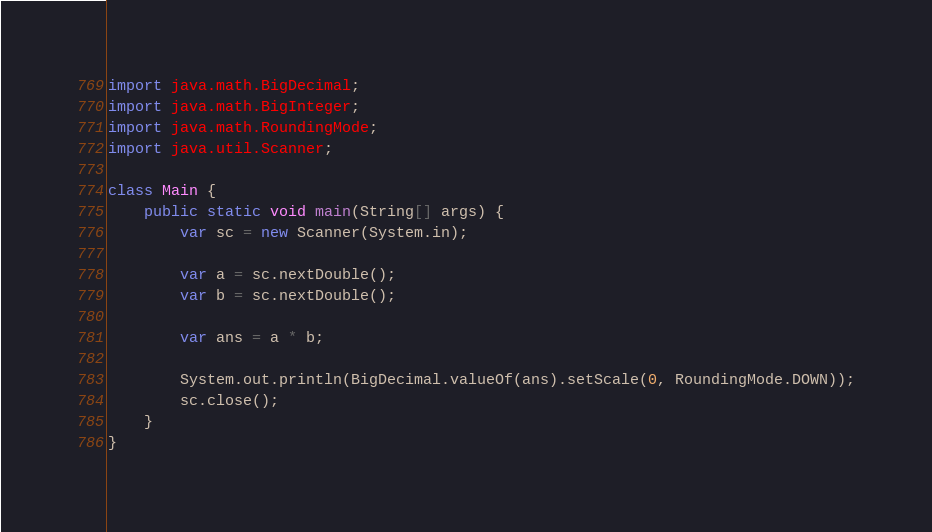Convert code to text. <code><loc_0><loc_0><loc_500><loc_500><_Java_>import java.math.BigDecimal;
import java.math.BigInteger;
import java.math.RoundingMode;
import java.util.Scanner;

class Main {
    public static void main(String[] args) {
        var sc = new Scanner(System.in);

        var a = sc.nextDouble();
        var b = sc.nextDouble();

        var ans = a * b;

        System.out.println(BigDecimal.valueOf(ans).setScale(0, RoundingMode.DOWN));
        sc.close();
    }
}</code> 